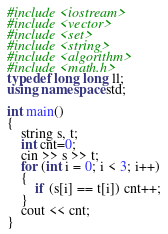<code> <loc_0><loc_0><loc_500><loc_500><_C++_>#include <iostream>
#include <vector>
#include <set>
#include <string>
#include <algorithm>
#include <math.h>
typedef long long ll;
using namespace std;

int main()
{
	string s, t;
	int cnt=0;
	cin >> s >> t;
	for (int i = 0; i < 3; i++)
	{
		if (s[i] == t[i]) cnt++;
	}
	cout << cnt;
}</code> 